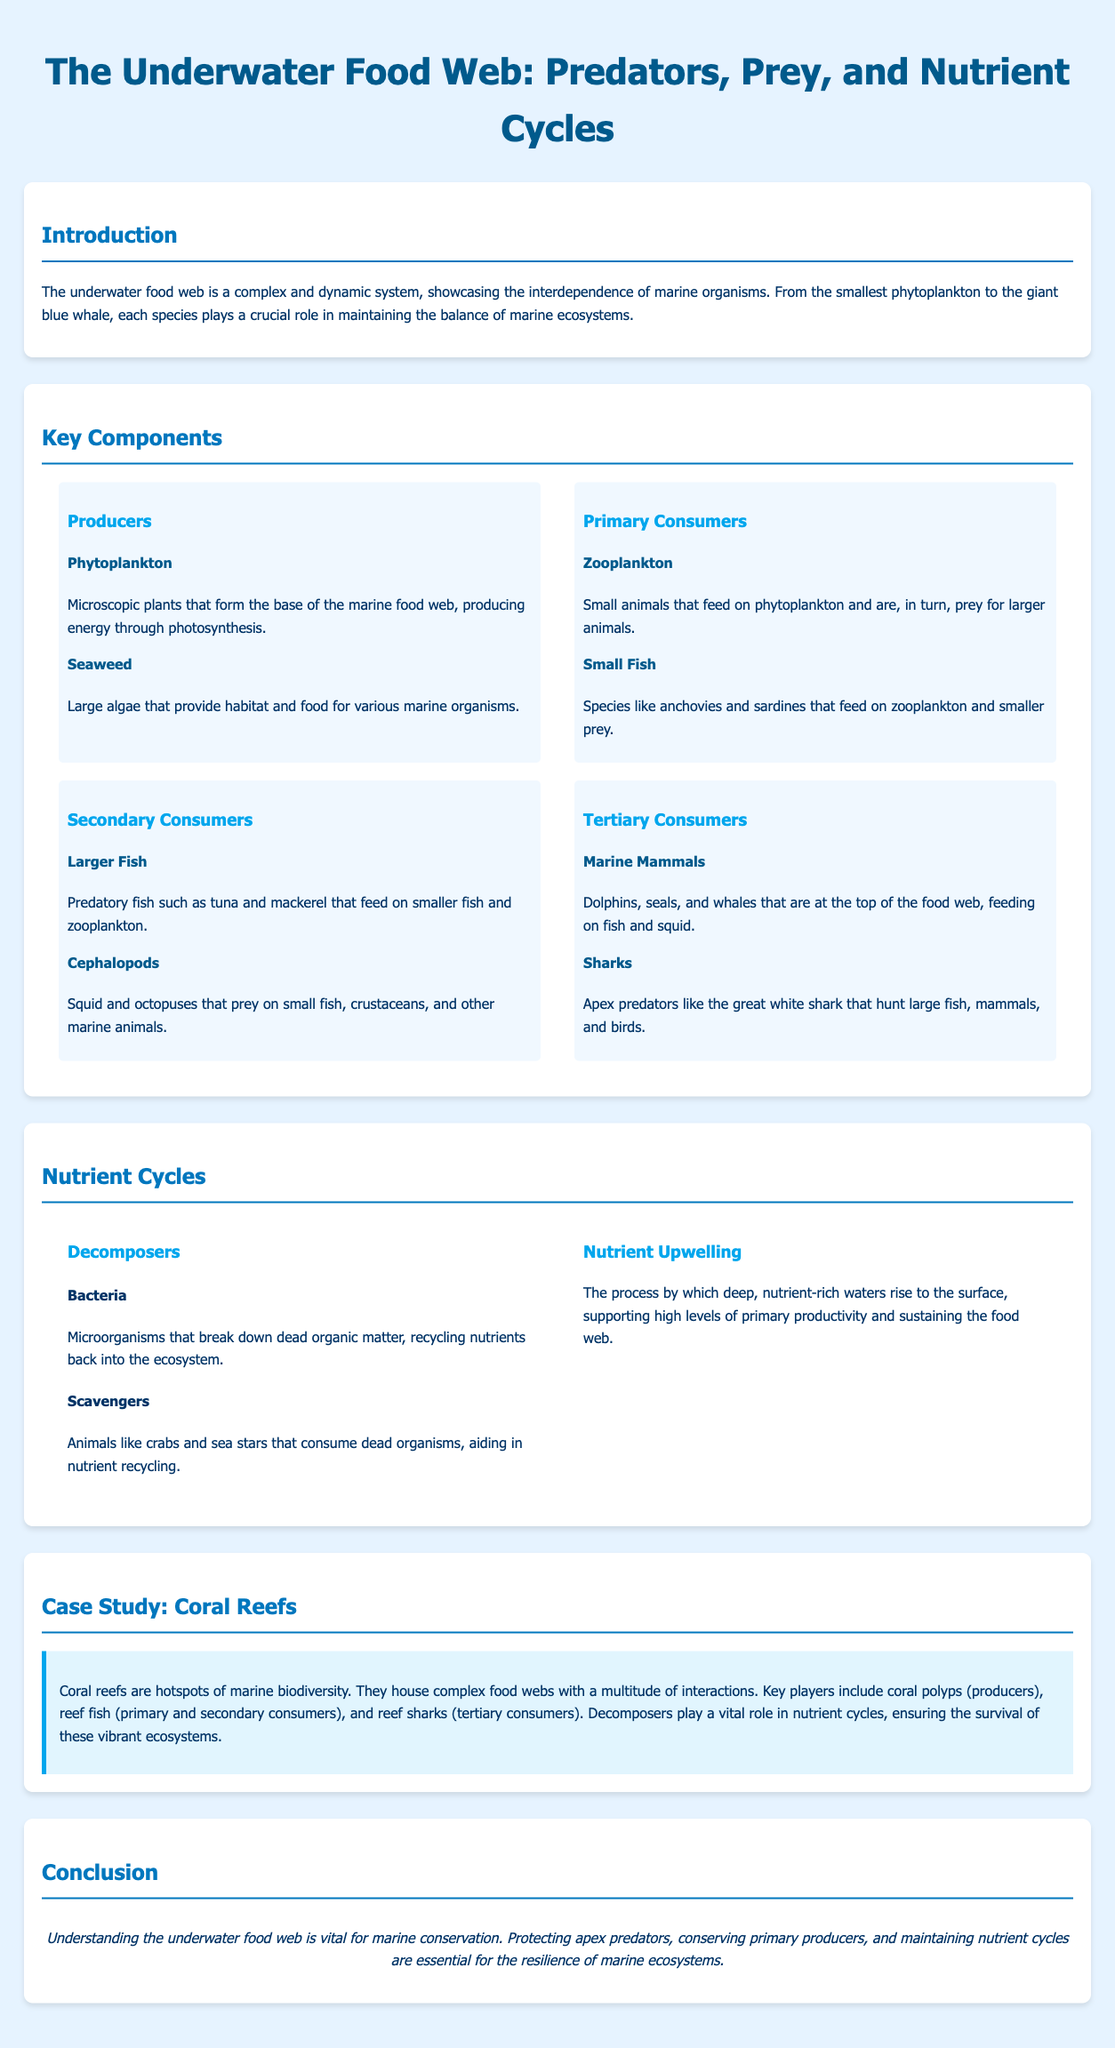What are the base producers in the underwater food web? The document states that phytoplankton and seaweed are the base producers that form the foundation of the marine food web.
Answer: Phytoplankton and seaweed Which marine mammals are considered tertiary consumers? According to the document, dolphins, seals, and whales are classified as tertiary consumers in the food web.
Answer: Dolphins, seals, and whales What role do bacteria play in the nutrient cycle? The document explains that bacteria are decomposers that break down dead organic matter, recycling nutrients back into the ecosystem.
Answer: Decomposers What process supports high levels of primary productivity? The document mentions nutrient upwelling as the process that supports high levels of primary productivity in the ocean.
Answer: Nutrient upwelling Name a primary consumer in the underwater food web. The document identifies zooplankton as a primary consumer that feeds on phytoplankton.
Answer: Zooplankton How do scavengers contribute to nutrient recycling? The document describes scavengers as animals that consume dead organisms, aiding in nutrient recycling within the ecosystem.
Answer: They consume dead organisms What is the primary focus of the case study mentioned? The case study primarily focuses on coral reefs as hotspots of marine biodiversity.
Answer: Coral reefs Which apex predator is mentioned in the document? The document highlights the great white shark as an apex predator in the underwater food web.
Answer: Great white shark What is vital for marine conservation according to the conclusion? The conclusion emphasizes the importance of protecting apex predators and maintaining nutrient cycles for marine conservation.
Answer: Protecting apex predators and maintaining nutrient cycles 